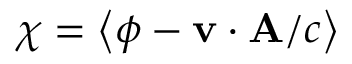Convert formula to latex. <formula><loc_0><loc_0><loc_500><loc_500>\chi = \left < \phi - \mathbf v \cdot \mathbf A / c \right ></formula> 